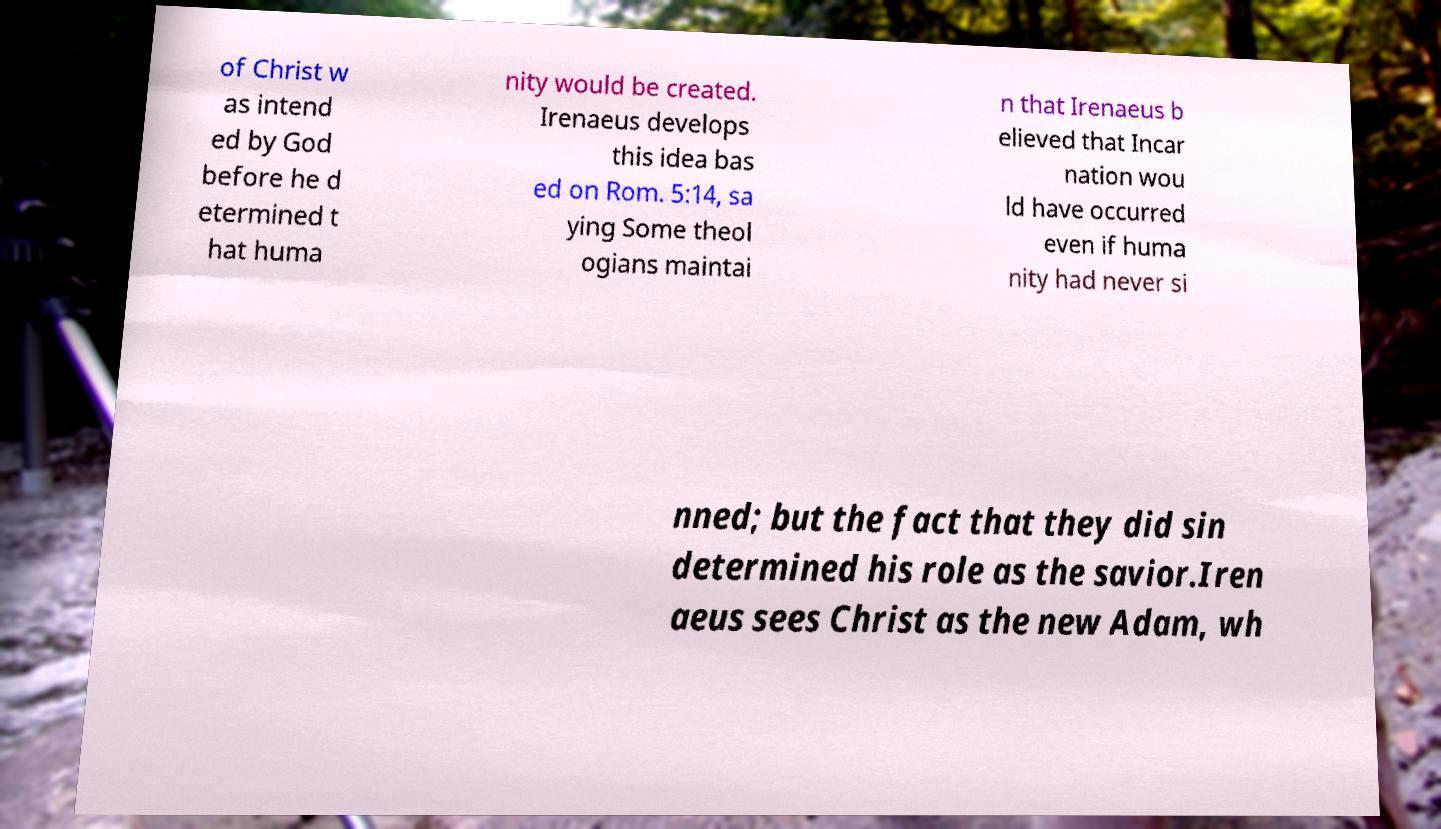Can you read and provide the text displayed in the image?This photo seems to have some interesting text. Can you extract and type it out for me? of Christ w as intend ed by God before he d etermined t hat huma nity would be created. Irenaeus develops this idea bas ed on Rom. 5:14, sa ying Some theol ogians maintai n that Irenaeus b elieved that Incar nation wou ld have occurred even if huma nity had never si nned; but the fact that they did sin determined his role as the savior.Iren aeus sees Christ as the new Adam, wh 